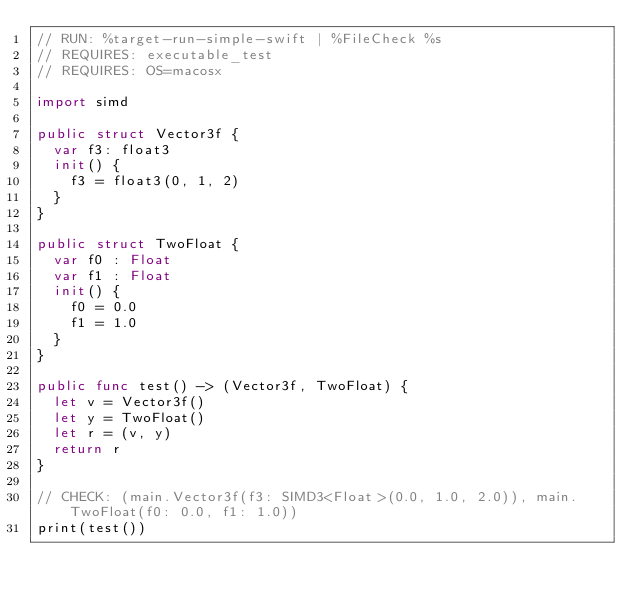Convert code to text. <code><loc_0><loc_0><loc_500><loc_500><_Swift_>// RUN: %target-run-simple-swift | %FileCheck %s
// REQUIRES: executable_test
// REQUIRES: OS=macosx

import simd

public struct Vector3f {
  var f3: float3
  init() {
    f3 = float3(0, 1, 2)
  }
}

public struct TwoFloat {
  var f0 : Float
  var f1 : Float
  init() {
    f0 = 0.0
    f1 = 1.0
  }
}

public func test() -> (Vector3f, TwoFloat) {
  let v = Vector3f()
  let y = TwoFloat()
  let r = (v, y)
  return r
}

// CHECK: (main.Vector3f(f3: SIMD3<Float>(0.0, 1.0, 2.0)), main.TwoFloat(f0: 0.0, f1: 1.0))
print(test())
</code> 